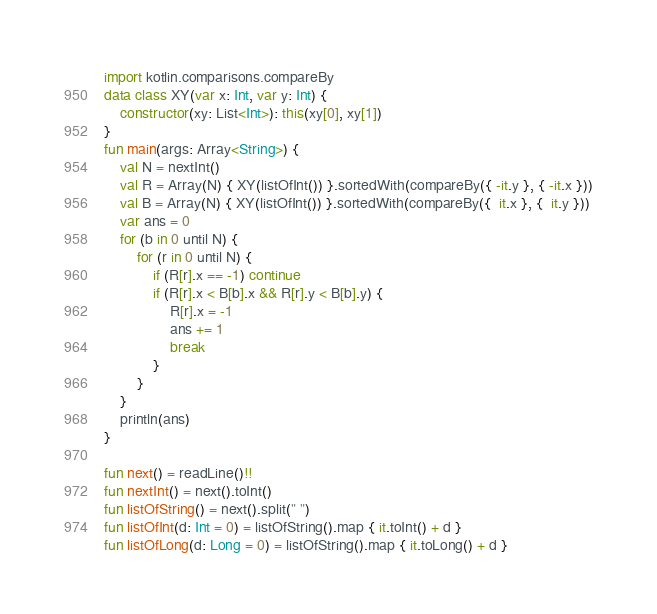Convert code to text. <code><loc_0><loc_0><loc_500><loc_500><_Kotlin_>import kotlin.comparisons.compareBy
data class XY(var x: Int, var y: Int) {
    constructor(xy: List<Int>): this(xy[0], xy[1])
}
fun main(args: Array<String>) {
    val N = nextInt()
    val R = Array(N) { XY(listOfInt()) }.sortedWith(compareBy({ -it.y }, { -it.x }))
    val B = Array(N) { XY(listOfInt()) }.sortedWith(compareBy({  it.x }, {  it.y }))
    var ans = 0
    for (b in 0 until N) {
        for (r in 0 until N) {
            if (R[r].x == -1) continue
            if (R[r].x < B[b].x && R[r].y < B[b].y) {
                R[r].x = -1
                ans += 1
                break
            }
        }
    }
    println(ans)
}

fun next() = readLine()!!
fun nextInt() = next().toInt()
fun listOfString() = next().split(" ")
fun listOfInt(d: Int = 0) = listOfString().map { it.toInt() + d }
fun listOfLong(d: Long = 0) = listOfString().map { it.toLong() + d }


</code> 